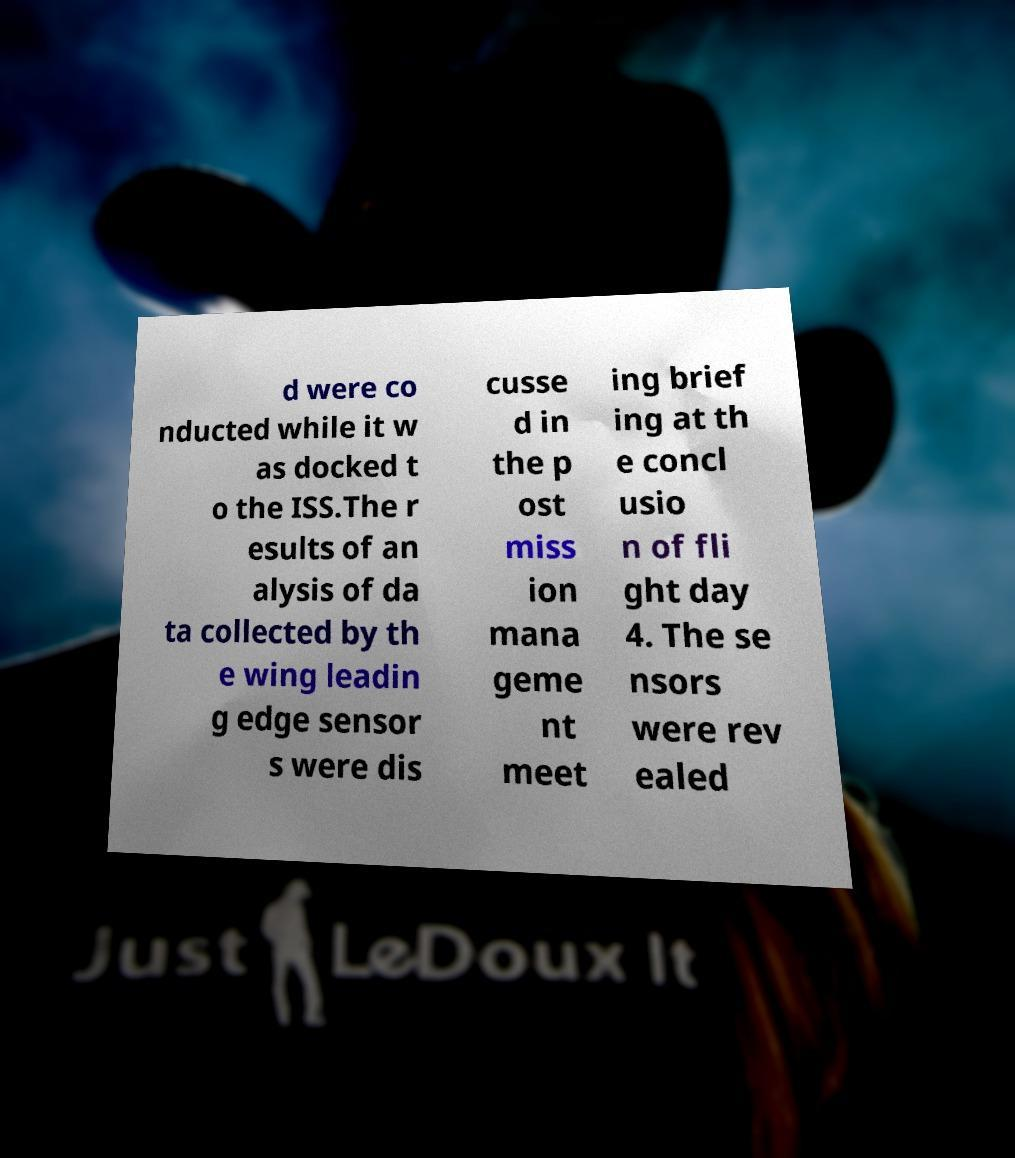Please read and relay the text visible in this image. What does it say? d were co nducted while it w as docked t o the ISS.The r esults of an alysis of da ta collected by th e wing leadin g edge sensor s were dis cusse d in the p ost miss ion mana geme nt meet ing brief ing at th e concl usio n of fli ght day 4. The se nsors were rev ealed 